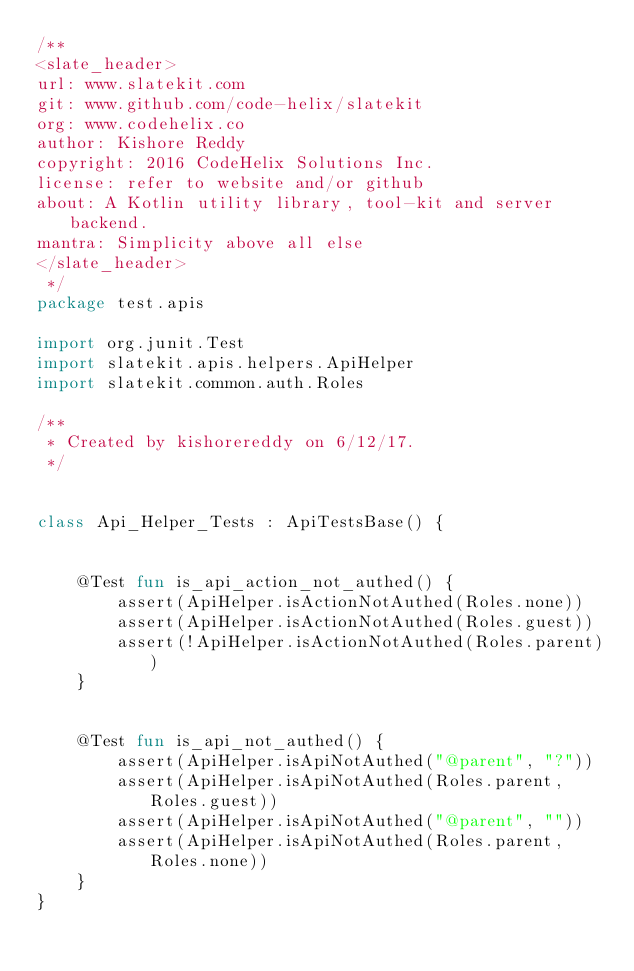<code> <loc_0><loc_0><loc_500><loc_500><_Kotlin_>/**
<slate_header>
url: www.slatekit.com
git: www.github.com/code-helix/slatekit
org: www.codehelix.co
author: Kishore Reddy
copyright: 2016 CodeHelix Solutions Inc.
license: refer to website and/or github
about: A Kotlin utility library, tool-kit and server backend.
mantra: Simplicity above all else
</slate_header>
 */
package test.apis

import org.junit.Test
import slatekit.apis.helpers.ApiHelper
import slatekit.common.auth.Roles

/**
 * Created by kishorereddy on 6/12/17.
 */


class Api_Helper_Tests : ApiTestsBase() {


    @Test fun is_api_action_not_authed() {
        assert(ApiHelper.isActionNotAuthed(Roles.none))
        assert(ApiHelper.isActionNotAuthed(Roles.guest))
        assert(!ApiHelper.isActionNotAuthed(Roles.parent))
    }


    @Test fun is_api_not_authed() {
        assert(ApiHelper.isApiNotAuthed("@parent", "?"))
        assert(ApiHelper.isApiNotAuthed(Roles.parent, Roles.guest))
        assert(ApiHelper.isApiNotAuthed("@parent", ""))
        assert(ApiHelper.isApiNotAuthed(Roles.parent, Roles.none))
    }
}
</code> 